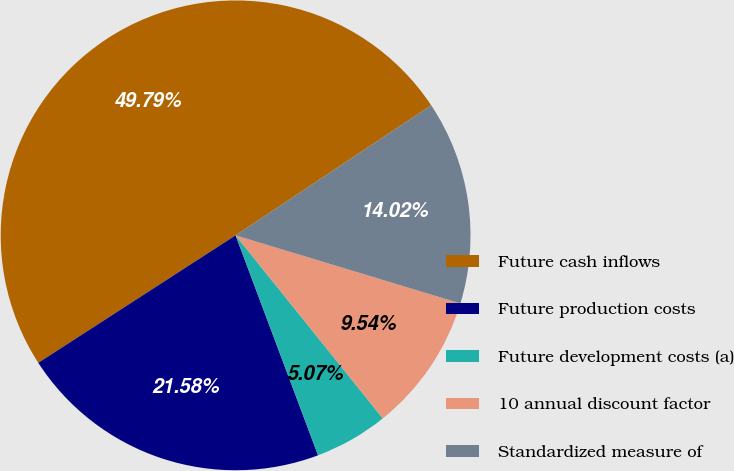<chart> <loc_0><loc_0><loc_500><loc_500><pie_chart><fcel>Future cash inflows<fcel>Future production costs<fcel>Future development costs (a)<fcel>10 annual discount factor<fcel>Standardized measure of<nl><fcel>49.79%<fcel>21.58%<fcel>5.07%<fcel>9.54%<fcel>14.02%<nl></chart> 